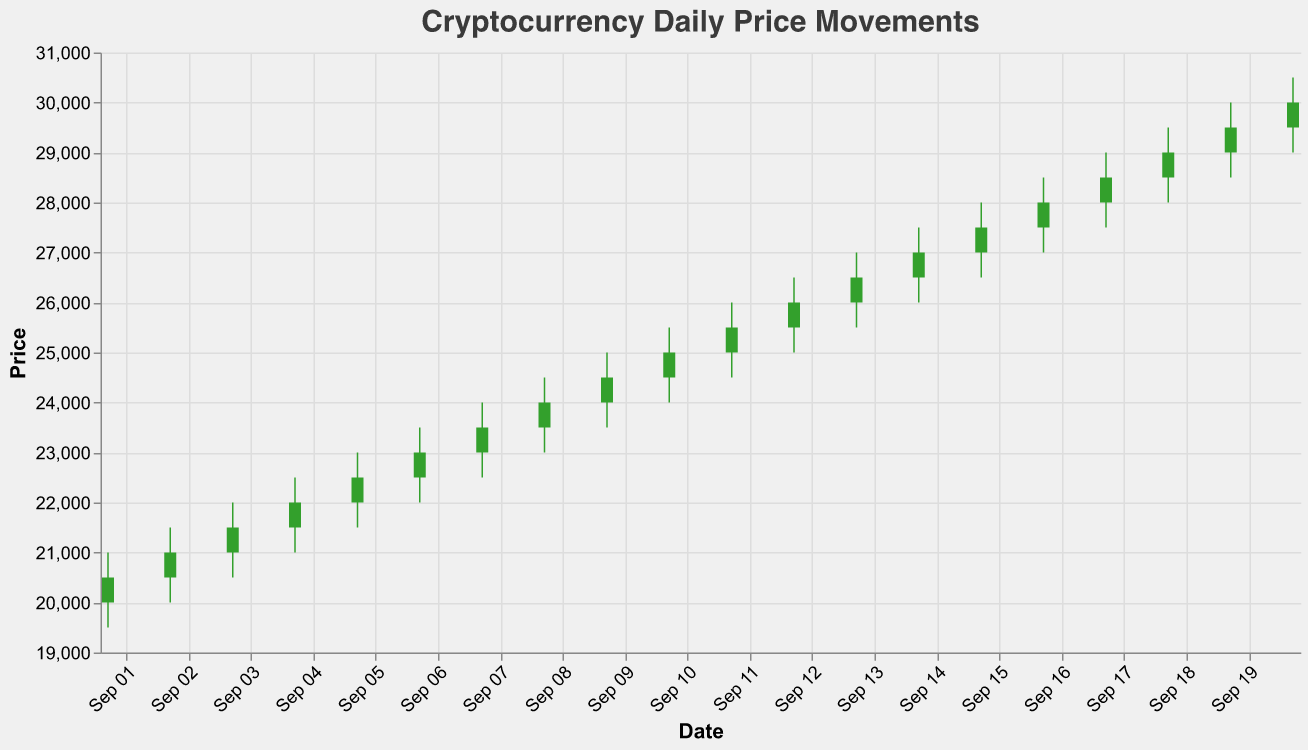What is the title of the figure? The title is displayed at the top of the figure and states what the plot represents. It reads "Cryptocurrency Daily Price Movements".
Answer: Cryptocurrency Daily Price Movements What is the highest price reached on September 20, 2022? By looking at the candlestick for September 20, 2022, we can see the top of the wick, which represents the highest price of the day.
Answer: 30500 What was the closing price on September 14, 2022? The closing price on each day can be observed by the top of the body of the candlestick if the color is green, or the bottom if the color is red. On September 14, 2022, the closing price is at the top of the green bar.
Answer: 27000 Which day had the largest trading volume? The trading volume can be compared across days to see which one is the tallest volume bar.
Answer: September 1, 2022 What was the price difference between the high and low on September 6, 2022? The high and low prices on September 6, 2022, are given as 23500 and 22000 respectively. The difference is 23500 - 22000.
Answer: 1500 How many days have a closing price higher than the opening price? Days with a closing price higher than the opening price are represented by green candlesticks. By counting the green candlesticks, we determine the number of such days.
Answer: 10 days On which day did the closing price fall below the opening price and what was the closing price? Red candlesticks indicate days when the closing price was lower than the opening price. After identifying such a day, we check the closing price at the bottom of the red body.
Answer: September 6, 2022, 23000 What was the average closing price over the given period? To find the average closing price, sum up all the daily closing prices and divide by the number of days. The sum of closing prices is 468500 (20500 + 21000 + ... + 30000). There are 20 days in total, so the average is 468500 / 20.
Answer: 23425 Which day had the highest volatility, and what was the range of the price movements that day? Volatility can be observed through the length of the candlestick's wick. The longest wick indicates the highest volatility, which represents the difference between high and low prices. The day with the longest wick is identified, and then the high and low prices for that day are noted.
Answer: September 13, 2022, 1500 